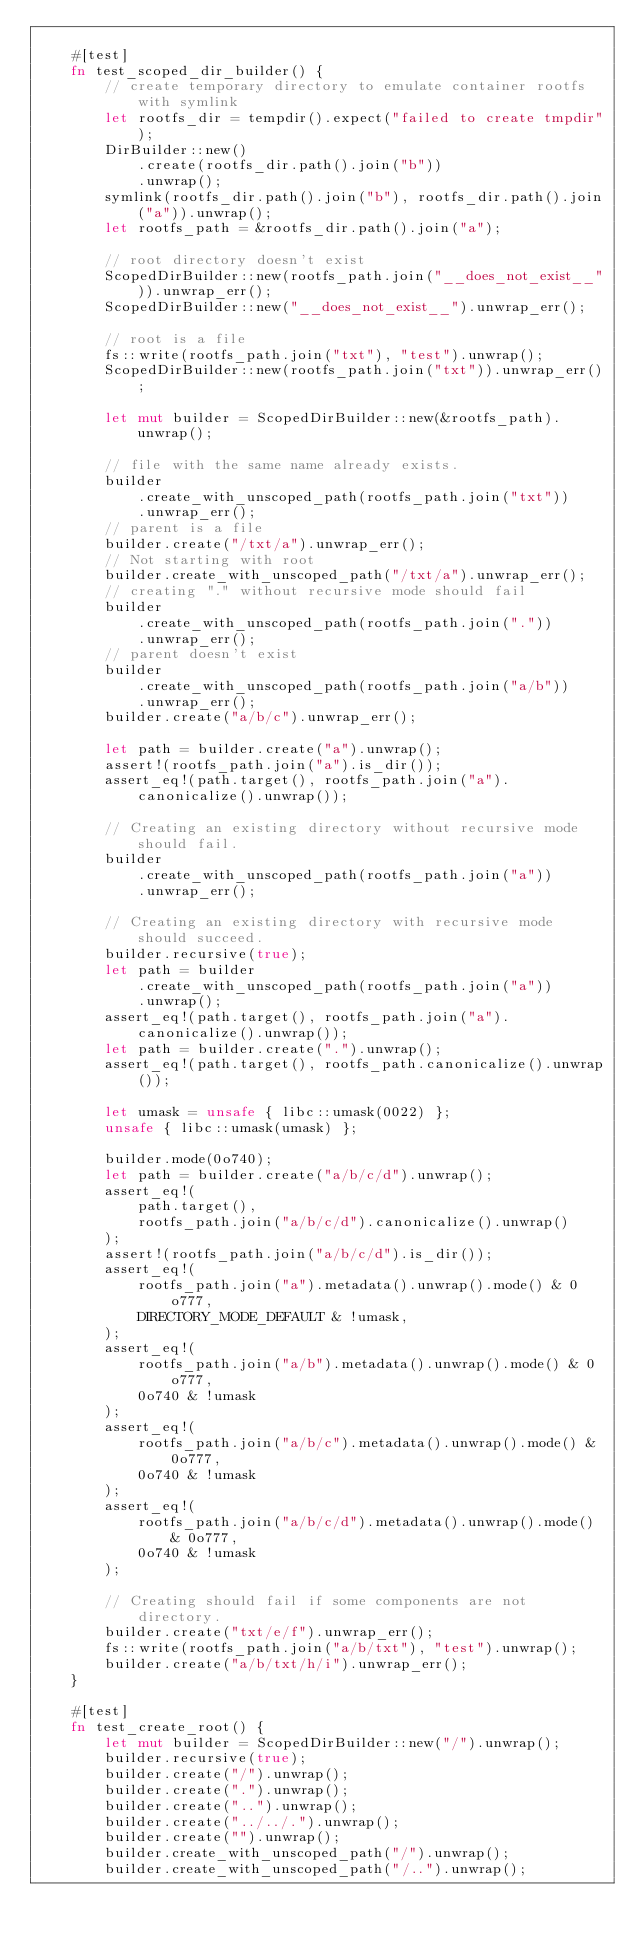<code> <loc_0><loc_0><loc_500><loc_500><_Rust_>
    #[test]
    fn test_scoped_dir_builder() {
        // create temporary directory to emulate container rootfs with symlink
        let rootfs_dir = tempdir().expect("failed to create tmpdir");
        DirBuilder::new()
            .create(rootfs_dir.path().join("b"))
            .unwrap();
        symlink(rootfs_dir.path().join("b"), rootfs_dir.path().join("a")).unwrap();
        let rootfs_path = &rootfs_dir.path().join("a");

        // root directory doesn't exist
        ScopedDirBuilder::new(rootfs_path.join("__does_not_exist__")).unwrap_err();
        ScopedDirBuilder::new("__does_not_exist__").unwrap_err();

        // root is a file
        fs::write(rootfs_path.join("txt"), "test").unwrap();
        ScopedDirBuilder::new(rootfs_path.join("txt")).unwrap_err();

        let mut builder = ScopedDirBuilder::new(&rootfs_path).unwrap();

        // file with the same name already exists.
        builder
            .create_with_unscoped_path(rootfs_path.join("txt"))
            .unwrap_err();
        // parent is a file
        builder.create("/txt/a").unwrap_err();
        // Not starting with root
        builder.create_with_unscoped_path("/txt/a").unwrap_err();
        // creating "." without recursive mode should fail
        builder
            .create_with_unscoped_path(rootfs_path.join("."))
            .unwrap_err();
        // parent doesn't exist
        builder
            .create_with_unscoped_path(rootfs_path.join("a/b"))
            .unwrap_err();
        builder.create("a/b/c").unwrap_err();

        let path = builder.create("a").unwrap();
        assert!(rootfs_path.join("a").is_dir());
        assert_eq!(path.target(), rootfs_path.join("a").canonicalize().unwrap());

        // Creating an existing directory without recursive mode should fail.
        builder
            .create_with_unscoped_path(rootfs_path.join("a"))
            .unwrap_err();

        // Creating an existing directory with recursive mode should succeed.
        builder.recursive(true);
        let path = builder
            .create_with_unscoped_path(rootfs_path.join("a"))
            .unwrap();
        assert_eq!(path.target(), rootfs_path.join("a").canonicalize().unwrap());
        let path = builder.create(".").unwrap();
        assert_eq!(path.target(), rootfs_path.canonicalize().unwrap());

        let umask = unsafe { libc::umask(0022) };
        unsafe { libc::umask(umask) };

        builder.mode(0o740);
        let path = builder.create("a/b/c/d").unwrap();
        assert_eq!(
            path.target(),
            rootfs_path.join("a/b/c/d").canonicalize().unwrap()
        );
        assert!(rootfs_path.join("a/b/c/d").is_dir());
        assert_eq!(
            rootfs_path.join("a").metadata().unwrap().mode() & 0o777,
            DIRECTORY_MODE_DEFAULT & !umask,
        );
        assert_eq!(
            rootfs_path.join("a/b").metadata().unwrap().mode() & 0o777,
            0o740 & !umask
        );
        assert_eq!(
            rootfs_path.join("a/b/c").metadata().unwrap().mode() & 0o777,
            0o740 & !umask
        );
        assert_eq!(
            rootfs_path.join("a/b/c/d").metadata().unwrap().mode() & 0o777,
            0o740 & !umask
        );

        // Creating should fail if some components are not directory.
        builder.create("txt/e/f").unwrap_err();
        fs::write(rootfs_path.join("a/b/txt"), "test").unwrap();
        builder.create("a/b/txt/h/i").unwrap_err();
    }

    #[test]
    fn test_create_root() {
        let mut builder = ScopedDirBuilder::new("/").unwrap();
        builder.recursive(true);
        builder.create("/").unwrap();
        builder.create(".").unwrap();
        builder.create("..").unwrap();
        builder.create("../../.").unwrap();
        builder.create("").unwrap();
        builder.create_with_unscoped_path("/").unwrap();
        builder.create_with_unscoped_path("/..").unwrap();</code> 